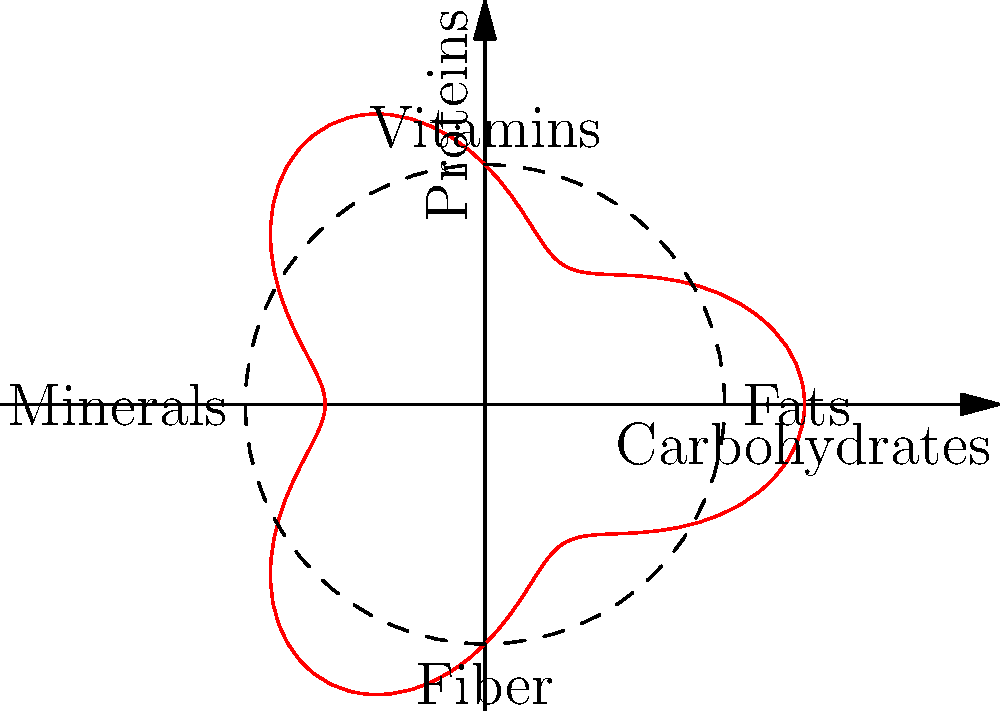As a chef experimenting with hormone-balancing recipes, you've created a meal represented by the polar curve $r = 3 + \cos(3\theta)$ to visualize its nutritional balance. The axes represent different nutrient groups: Carbohydrates (x-axis), Proteins (y-axis), Fats (positive x), Vitamins (positive y), Minerals (negative x), and Fiber (negative y). What is the maximum radial distance from the origin to any point on the curve, and what does this distance represent in terms of nutritional balance? To find the maximum radial distance, we need to follow these steps:

1) The radial distance is given by the function $r = 3 + \cos(3\theta)$.

2) The maximum value will occur when $\cos(3\theta)$ is at its maximum, which is 1.

3) Therefore, the maximum radial distance is:

   $r_{max} = 3 + 1 = 4$

4) This occurs when $\cos(3\theta) = 1$, which happens when $3\theta = 0, 2\pi, 4\pi, ...$ or $\theta = 0, \frac{2\pi}{3}, \frac{4\pi}{3}$.

5) In the context of nutritional balance, the maximum radial distance represents the highest concentration of nutrients in the meal. 

6) Since this occurs at $\theta = 0, \frac{2\pi}{3}, \frac{4\pi}{3}$, it means the meal has peak nutritional content in carbohydrates, minerals, and fiber.

7) The value of 4 (compared to the base circle of radius 3) indicates that these nutrients are present in quantities 33% higher than the baseline nutritional content.
Answer: Maximum radial distance is 4, representing 33% higher concentration of carbohydrates, minerals, and fiber. 